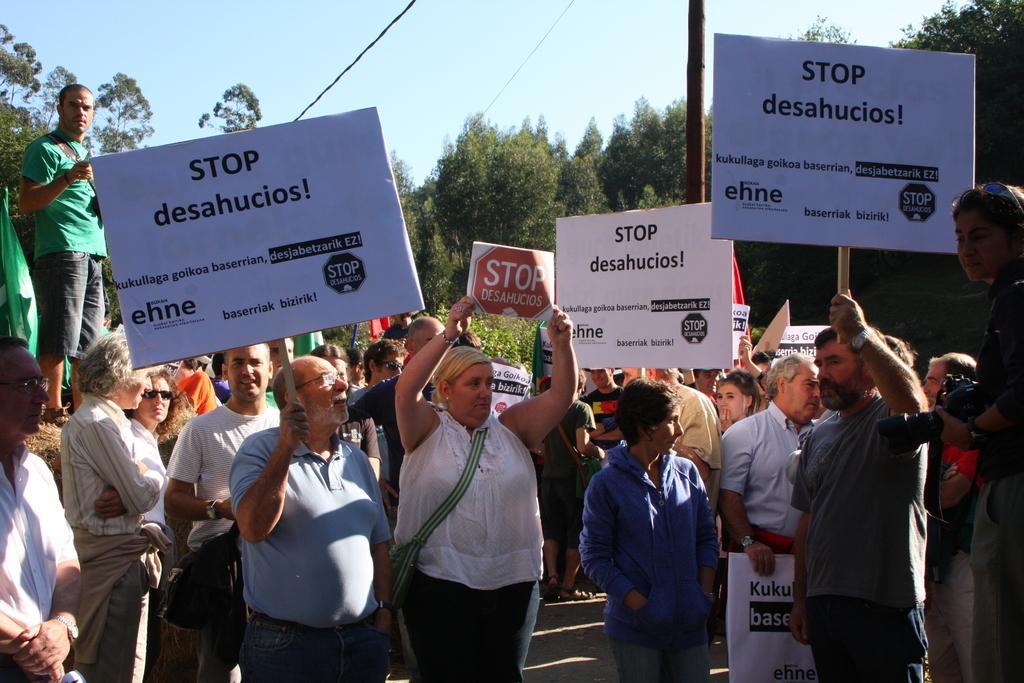Please provide a concise description of this image. In this image we can see few people standing on the road and holding pluck card and in the background there are few trees, a pole with wires and the sky. 